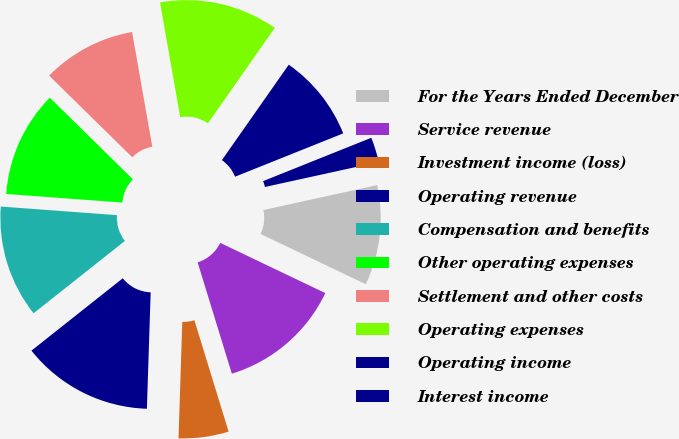Convert chart to OTSL. <chart><loc_0><loc_0><loc_500><loc_500><pie_chart><fcel>For the Years Ended December<fcel>Service revenue<fcel>Investment income (loss)<fcel>Operating revenue<fcel>Compensation and benefits<fcel>Other operating expenses<fcel>Settlement and other costs<fcel>Operating expenses<fcel>Operating income<fcel>Interest income<nl><fcel>10.53%<fcel>13.16%<fcel>5.26%<fcel>13.82%<fcel>11.84%<fcel>11.18%<fcel>9.87%<fcel>12.5%<fcel>9.21%<fcel>2.63%<nl></chart> 